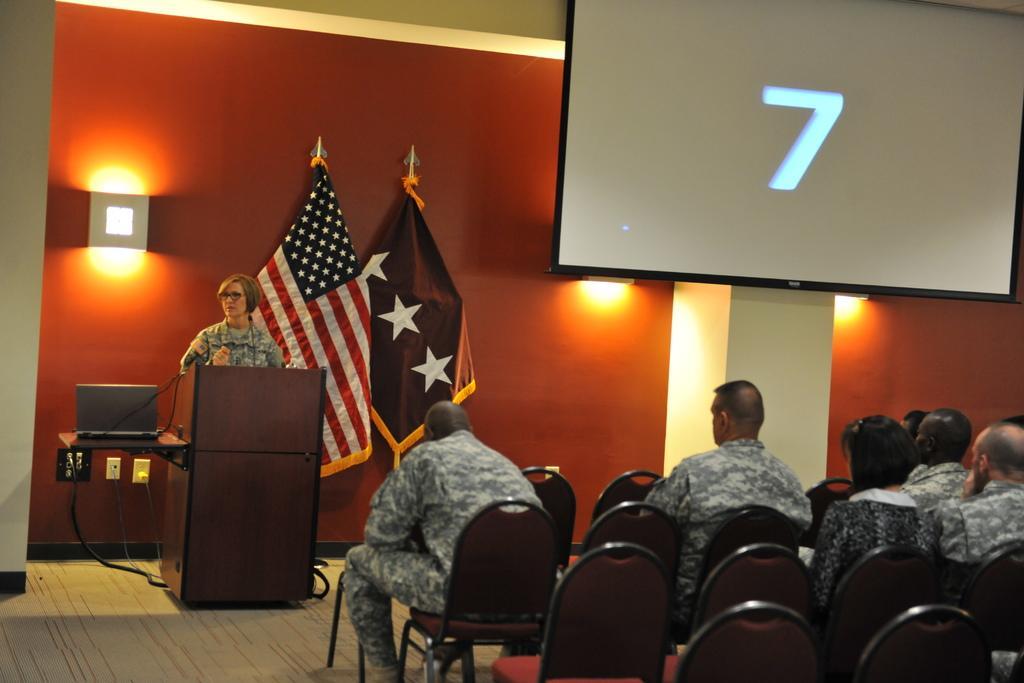How would you summarize this image in a sentence or two? This picture shows few people seated on the chairs and we see a woman standing and speaking at a podium and we see a laptop on the side and couple of flags and we see lights to the wall and a television displaying a number on the screen. 